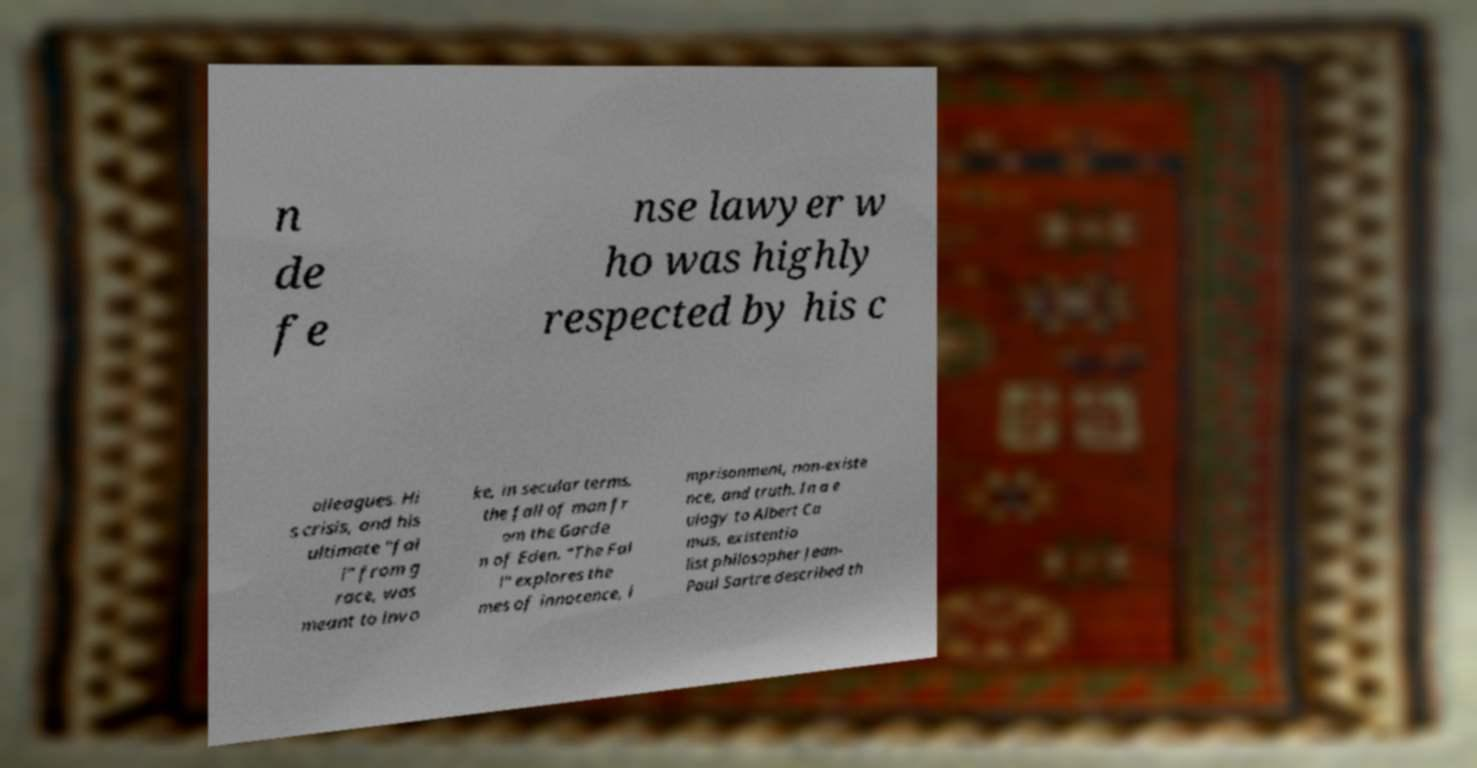Can you read and provide the text displayed in the image?This photo seems to have some interesting text. Can you extract and type it out for me? n de fe nse lawyer w ho was highly respected by his c olleagues. Hi s crisis, and his ultimate "fal l" from g race, was meant to invo ke, in secular terms, the fall of man fr om the Garde n of Eden. "The Fal l" explores the mes of innocence, i mprisonment, non-existe nce, and truth. In a e ulogy to Albert Ca mus, existentia list philosopher Jean- Paul Sartre described th 